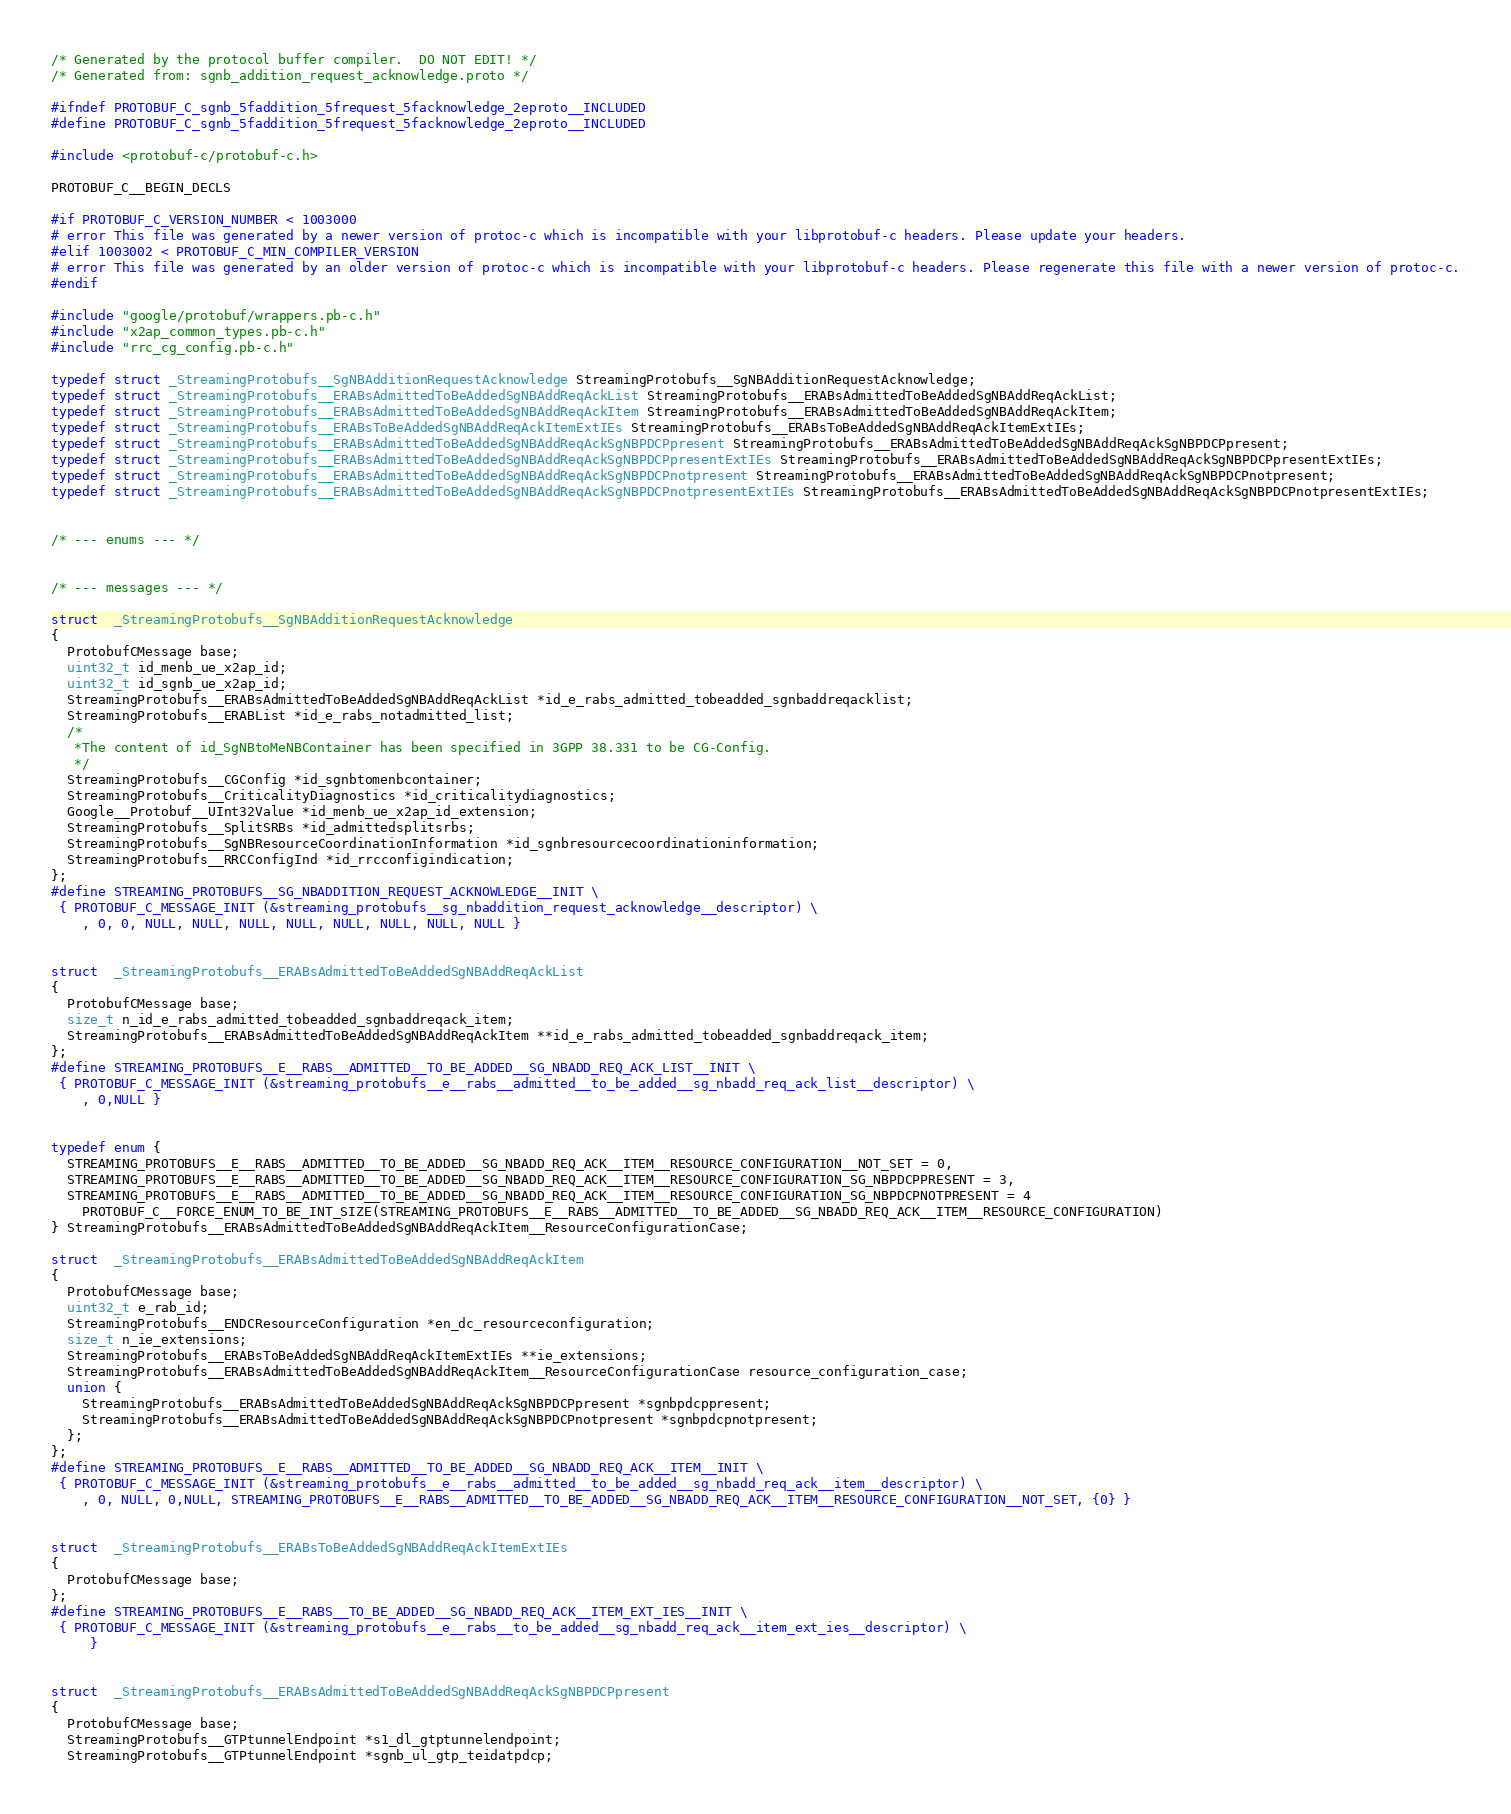<code> <loc_0><loc_0><loc_500><loc_500><_C_>/* Generated by the protocol buffer compiler.  DO NOT EDIT! */
/* Generated from: sgnb_addition_request_acknowledge.proto */

#ifndef PROTOBUF_C_sgnb_5faddition_5frequest_5facknowledge_2eproto__INCLUDED
#define PROTOBUF_C_sgnb_5faddition_5frequest_5facknowledge_2eproto__INCLUDED

#include <protobuf-c/protobuf-c.h>

PROTOBUF_C__BEGIN_DECLS

#if PROTOBUF_C_VERSION_NUMBER < 1003000
# error This file was generated by a newer version of protoc-c which is incompatible with your libprotobuf-c headers. Please update your headers.
#elif 1003002 < PROTOBUF_C_MIN_COMPILER_VERSION
# error This file was generated by an older version of protoc-c which is incompatible with your libprotobuf-c headers. Please regenerate this file with a newer version of protoc-c.
#endif

#include "google/protobuf/wrappers.pb-c.h"
#include "x2ap_common_types.pb-c.h"
#include "rrc_cg_config.pb-c.h"

typedef struct _StreamingProtobufs__SgNBAdditionRequestAcknowledge StreamingProtobufs__SgNBAdditionRequestAcknowledge;
typedef struct _StreamingProtobufs__ERABsAdmittedToBeAddedSgNBAddReqAckList StreamingProtobufs__ERABsAdmittedToBeAddedSgNBAddReqAckList;
typedef struct _StreamingProtobufs__ERABsAdmittedToBeAddedSgNBAddReqAckItem StreamingProtobufs__ERABsAdmittedToBeAddedSgNBAddReqAckItem;
typedef struct _StreamingProtobufs__ERABsToBeAddedSgNBAddReqAckItemExtIEs StreamingProtobufs__ERABsToBeAddedSgNBAddReqAckItemExtIEs;
typedef struct _StreamingProtobufs__ERABsAdmittedToBeAddedSgNBAddReqAckSgNBPDCPpresent StreamingProtobufs__ERABsAdmittedToBeAddedSgNBAddReqAckSgNBPDCPpresent;
typedef struct _StreamingProtobufs__ERABsAdmittedToBeAddedSgNBAddReqAckSgNBPDCPpresentExtIEs StreamingProtobufs__ERABsAdmittedToBeAddedSgNBAddReqAckSgNBPDCPpresentExtIEs;
typedef struct _StreamingProtobufs__ERABsAdmittedToBeAddedSgNBAddReqAckSgNBPDCPnotpresent StreamingProtobufs__ERABsAdmittedToBeAddedSgNBAddReqAckSgNBPDCPnotpresent;
typedef struct _StreamingProtobufs__ERABsAdmittedToBeAddedSgNBAddReqAckSgNBPDCPnotpresentExtIEs StreamingProtobufs__ERABsAdmittedToBeAddedSgNBAddReqAckSgNBPDCPnotpresentExtIEs;


/* --- enums --- */


/* --- messages --- */

struct  _StreamingProtobufs__SgNBAdditionRequestAcknowledge
{
  ProtobufCMessage base;
  uint32_t id_menb_ue_x2ap_id;
  uint32_t id_sgnb_ue_x2ap_id;
  StreamingProtobufs__ERABsAdmittedToBeAddedSgNBAddReqAckList *id_e_rabs_admitted_tobeadded_sgnbaddreqacklist;
  StreamingProtobufs__ERABList *id_e_rabs_notadmitted_list;
  /*
   *The content of id_SgNBtoMeNBContainer has been specified in 3GPP 38.331 to be CG-Config.
   */
  StreamingProtobufs__CGConfig *id_sgnbtomenbcontainer;
  StreamingProtobufs__CriticalityDiagnostics *id_criticalitydiagnostics;
  Google__Protobuf__UInt32Value *id_menb_ue_x2ap_id_extension;
  StreamingProtobufs__SplitSRBs *id_admittedsplitsrbs;
  StreamingProtobufs__SgNBResourceCoordinationInformation *id_sgnbresourcecoordinationinformation;
  StreamingProtobufs__RRCConfigInd *id_rrcconfigindication;
};
#define STREAMING_PROTOBUFS__SG_NBADDITION_REQUEST_ACKNOWLEDGE__INIT \
 { PROTOBUF_C_MESSAGE_INIT (&streaming_protobufs__sg_nbaddition_request_acknowledge__descriptor) \
    , 0, 0, NULL, NULL, NULL, NULL, NULL, NULL, NULL, NULL }


struct  _StreamingProtobufs__ERABsAdmittedToBeAddedSgNBAddReqAckList
{
  ProtobufCMessage base;
  size_t n_id_e_rabs_admitted_tobeadded_sgnbaddreqack_item;
  StreamingProtobufs__ERABsAdmittedToBeAddedSgNBAddReqAckItem **id_e_rabs_admitted_tobeadded_sgnbaddreqack_item;
};
#define STREAMING_PROTOBUFS__E__RABS__ADMITTED__TO_BE_ADDED__SG_NBADD_REQ_ACK_LIST__INIT \
 { PROTOBUF_C_MESSAGE_INIT (&streaming_protobufs__e__rabs__admitted__to_be_added__sg_nbadd_req_ack_list__descriptor) \
    , 0,NULL }


typedef enum {
  STREAMING_PROTOBUFS__E__RABS__ADMITTED__TO_BE_ADDED__SG_NBADD_REQ_ACK__ITEM__RESOURCE_CONFIGURATION__NOT_SET = 0,
  STREAMING_PROTOBUFS__E__RABS__ADMITTED__TO_BE_ADDED__SG_NBADD_REQ_ACK__ITEM__RESOURCE_CONFIGURATION_SG_NBPDCPPRESENT = 3,
  STREAMING_PROTOBUFS__E__RABS__ADMITTED__TO_BE_ADDED__SG_NBADD_REQ_ACK__ITEM__RESOURCE_CONFIGURATION_SG_NBPDCPNOTPRESENT = 4
    PROTOBUF_C__FORCE_ENUM_TO_BE_INT_SIZE(STREAMING_PROTOBUFS__E__RABS__ADMITTED__TO_BE_ADDED__SG_NBADD_REQ_ACK__ITEM__RESOURCE_CONFIGURATION)
} StreamingProtobufs__ERABsAdmittedToBeAddedSgNBAddReqAckItem__ResourceConfigurationCase;

struct  _StreamingProtobufs__ERABsAdmittedToBeAddedSgNBAddReqAckItem
{
  ProtobufCMessage base;
  uint32_t e_rab_id;
  StreamingProtobufs__ENDCResourceConfiguration *en_dc_resourceconfiguration;
  size_t n_ie_extensions;
  StreamingProtobufs__ERABsToBeAddedSgNBAddReqAckItemExtIEs **ie_extensions;
  StreamingProtobufs__ERABsAdmittedToBeAddedSgNBAddReqAckItem__ResourceConfigurationCase resource_configuration_case;
  union {
    StreamingProtobufs__ERABsAdmittedToBeAddedSgNBAddReqAckSgNBPDCPpresent *sgnbpdcppresent;
    StreamingProtobufs__ERABsAdmittedToBeAddedSgNBAddReqAckSgNBPDCPnotpresent *sgnbpdcpnotpresent;
  };
};
#define STREAMING_PROTOBUFS__E__RABS__ADMITTED__TO_BE_ADDED__SG_NBADD_REQ_ACK__ITEM__INIT \
 { PROTOBUF_C_MESSAGE_INIT (&streaming_protobufs__e__rabs__admitted__to_be_added__sg_nbadd_req_ack__item__descriptor) \
    , 0, NULL, 0,NULL, STREAMING_PROTOBUFS__E__RABS__ADMITTED__TO_BE_ADDED__SG_NBADD_REQ_ACK__ITEM__RESOURCE_CONFIGURATION__NOT_SET, {0} }


struct  _StreamingProtobufs__ERABsToBeAddedSgNBAddReqAckItemExtIEs
{
  ProtobufCMessage base;
};
#define STREAMING_PROTOBUFS__E__RABS__TO_BE_ADDED__SG_NBADD_REQ_ACK__ITEM_EXT_IES__INIT \
 { PROTOBUF_C_MESSAGE_INIT (&streaming_protobufs__e__rabs__to_be_added__sg_nbadd_req_ack__item_ext_ies__descriptor) \
     }


struct  _StreamingProtobufs__ERABsAdmittedToBeAddedSgNBAddReqAckSgNBPDCPpresent
{
  ProtobufCMessage base;
  StreamingProtobufs__GTPtunnelEndpoint *s1_dl_gtptunnelendpoint;
  StreamingProtobufs__GTPtunnelEndpoint *sgnb_ul_gtp_teidatpdcp;</code> 